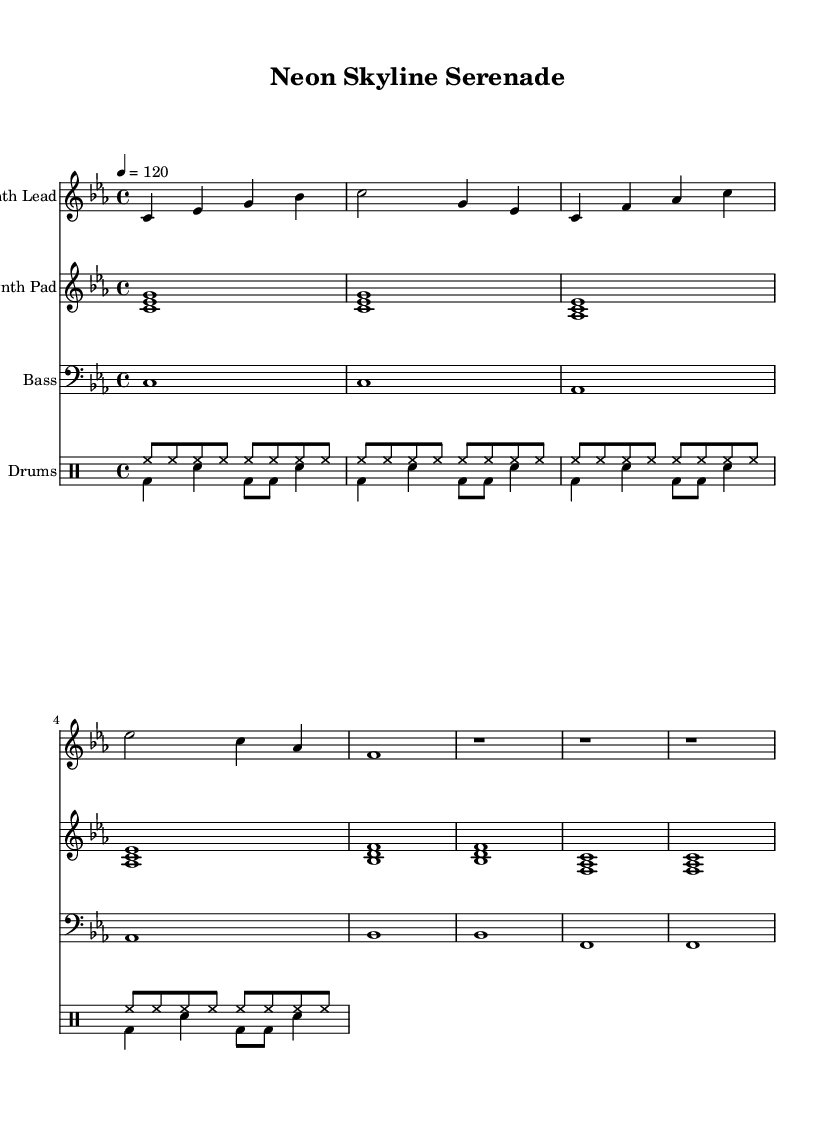What is the key signature of this music? The key signature displayed in the sheet music is C minor, which contains three flats: B♭, E♭, and A♭. This is indicated at the beginning of the staff.
Answer: C minor What is the time signature of this music? The time signature indicated in the sheet music is 4/4, meaning there are four beats per measure. This is found at the start of the piece.
Answer: 4/4 What is the tempo marking for this piece? The tempo marking shows that the piece should be played at a speed of 120 beats per minute, which is indicated as "4 = 120" at the beginning of the score.
Answer: 120 How many measures are in the Synth Lead section? The Synth Lead section has 12 measures, which can be counted by looking at the bar lines throughout the music.
Answer: 12 Which instruments are featured in this score? The score includes four instruments: Synth Lead, Synth Pad, Bass, and Drums, as labeled clearly at the beginning of each staff.
Answer: Synth Lead, Synth Pad, Bass, Drums What rhythmic pattern is used in the drum section? The drum section uses a combination of hi-hat and bass drum patterns that are consistent across the measures, with hi-hat played consistently in eighth notes and bass drum and snare creating a syncopated feel.
Answer: Hi-hat in eighth notes, bass and snare pattern How does the bass line vary over the course of the piece? The bass line uses a repeating pattern that changes pitches: starting with C, then moving to A♭, B♭, and F, demonstrating a clear movement and structure across the measures.
Answer: Changes from C to A♭, B♭, F 